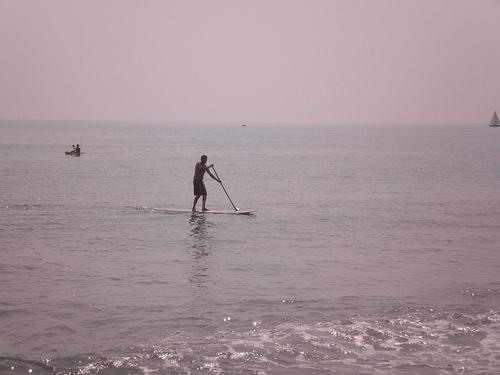Identify the main activity happening in the image and describe the scene in detail. A man is paddleboarding on calm and soothing sea water, surrounded by small ripples and waves, under a gray and overcast sky. What is the position of the man on his board and what is he holding? The man is standing on his surfboard while balancing, and he is holding a paddle with his right hand. What is a noticeable detail about the man's attire and appearance? The man is wearing shorts, but he is not wearing shoes, and he has short hair. Comment on the condition of the water and the presence of other objects in the scene. The water is calm with small ripples and waves, and there is a sailboat in the distance, people fishing and a couple on a sailboat. Identify and describe elements contributing to the peaceful atmosphere of the image. The overcast sky with soothing gray colors, the calm water, and the man paddleboarding gracefully contribute to the peaceful atmosphere. Describe how the man is interacting with the water as he paddleboards. The man is standing on his board, using the paddle to maneuver through the water, creating little splashes and smaller waves. What are some secondary elements in the image besides the main subject? Secondary elements include a sailboat, people fishing, a couple on a sailboat, and ripples in the water. What is the color of the sky and what does it make the atmosphere look like? The sky is gray and fuzzy, giving the atmosphere a smoky and overcast appearance. Mention a distinguishing feature of the man's board in relation to water, and describe the ripples in detail. The board is partially submerged in the water, and the ripples are small and gentle, scattered around the board and across the calm sea surface. Briefly describe the person engaged in the water activity and what they are wearing. The person paddleboarding is a man with short hair, wearing shorts and not wearing shoes. 